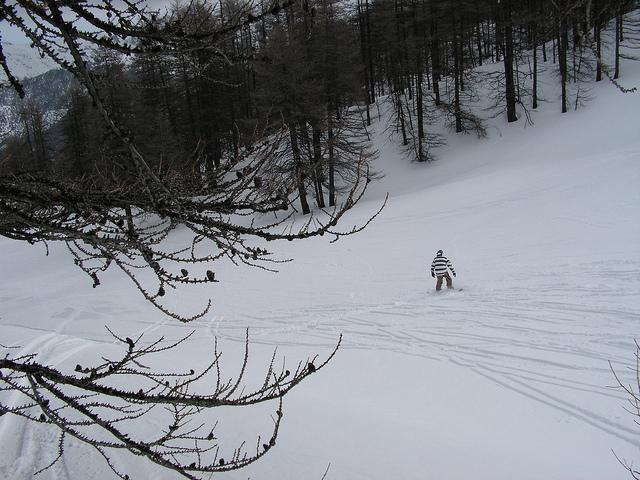What are the little bumps on the tree branches? Please explain your reasoning. seed cones. They are the pods that ensure the tree species will continue to grow for years 